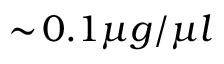Convert formula to latex. <formula><loc_0><loc_0><loc_500><loc_500>\sim \, 0 . 1 \mu g / \mu l</formula> 